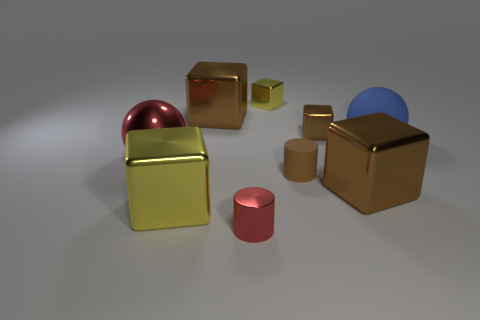Subtract all brown cubes. How many were subtracted if there are1brown cubes left? 2 Subtract all small metal blocks. How many blocks are left? 3 Add 1 large metallic objects. How many objects exist? 10 Subtract all brown cylinders. How many cylinders are left? 1 Subtract 1 balls. How many balls are left? 1 Subtract all balls. How many objects are left? 7 Subtract all blue cubes. How many gray balls are left? 0 Subtract all big metal blocks. Subtract all blue rubber spheres. How many objects are left? 5 Add 3 large red balls. How many large red balls are left? 4 Add 5 small blue rubber blocks. How many small blue rubber blocks exist? 5 